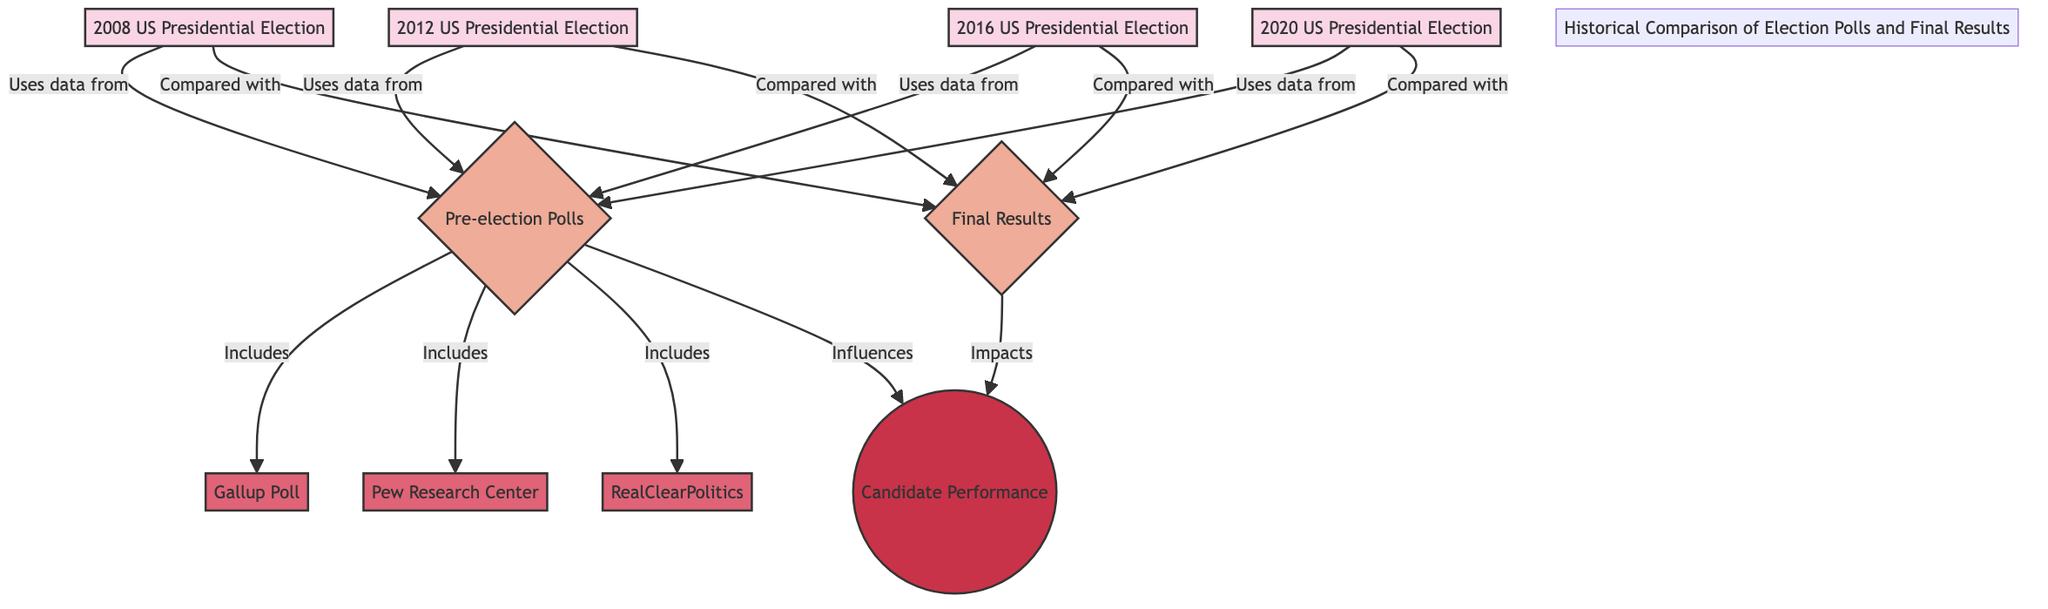What events are compared to final results in this diagram? The diagram indicates that the events compared with final results are the 2008, 2012, 2016, and 2020 US Presidential Elections. These events are all linked to the final results node, showing direct comparisons.
Answer: 2008, 2012, 2016, 2020 US Presidential Elections How many sources are mentioned in relation to pre-election polls? The diagram lists three sources that are included in the pre-election polls, which are Gallup Poll, Pew Research Center, and RealClearPolitics. Counting these gives the number of sources mentioned.
Answer: 3 What category impacts candidate performance in the diagram? The diagram shows that the final results category impacts candidate performance. It directly connects the final results to the candidate performance concept, indicating a key influence.
Answer: Final Results Which category is linked to both pre-election polls and final results? The pre-election polls category is linked to the final results category through the events of the elections. The structure suggests that both are involved in shaping the comparisons made.
Answer: Pre-election Polls Which election used data from the pre-election polls? The diagram indicates that all four elections (2008, 2012, 2016, and 2020) utilize data from the pre-election polls. They all point back to the same category for sourcing their data.
Answer: 2008, 2012, 2016, 2020 What does the node "Candidate Performance" represent in relation to the diagram? The node labeled "Candidate Performance" represents an outcome that is impacted by both pre-election polls and final results. It signifies a conceptual tie to the effectiveness or success of candidates based on polling data and election outcomes.
Answer: Outcome How do pre-election polls influence the final results? The diagram illustrates that pre-election polls influence the final results by showing that the data used for the elections draws upon the polls. The arrows indicate a directional influence, linking the two categories.
Answer: Influence What subgraph title is given in the diagram? The title 'Historical Comparison of Election Polls and Final Results' is given as part of a subgraph title in order to contextualize the components and their relationships throughout the diagram.
Answer: Historical Comparison of Election Polls and Final Results 